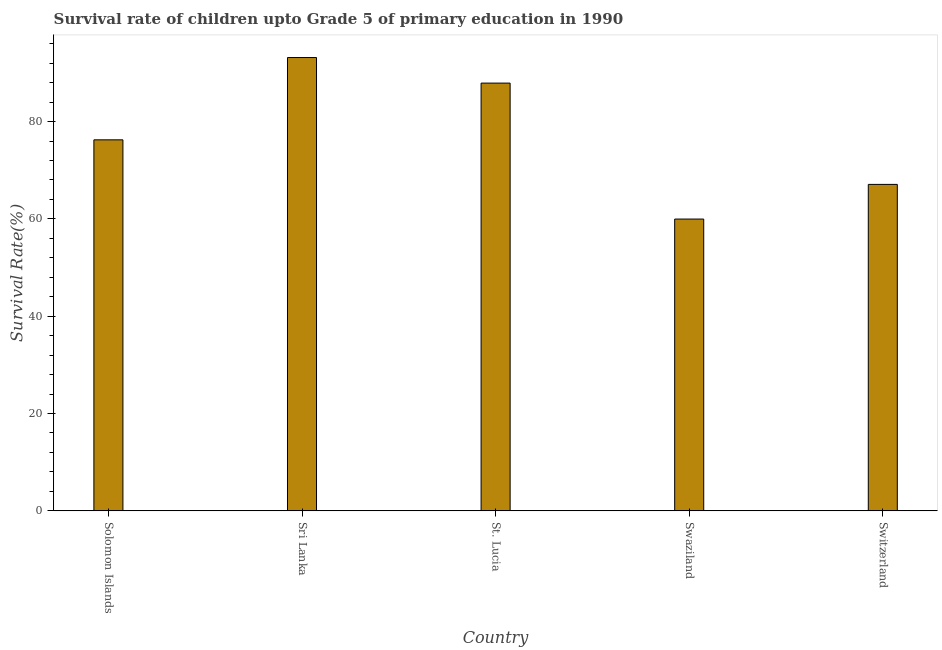Does the graph contain any zero values?
Your response must be concise. No. What is the title of the graph?
Ensure brevity in your answer.  Survival rate of children upto Grade 5 of primary education in 1990 . What is the label or title of the Y-axis?
Keep it short and to the point. Survival Rate(%). What is the survival rate in St. Lucia?
Ensure brevity in your answer.  87.9. Across all countries, what is the maximum survival rate?
Your answer should be very brief. 93.16. Across all countries, what is the minimum survival rate?
Ensure brevity in your answer.  59.96. In which country was the survival rate maximum?
Ensure brevity in your answer.  Sri Lanka. In which country was the survival rate minimum?
Keep it short and to the point. Swaziland. What is the sum of the survival rate?
Keep it short and to the point. 384.35. What is the difference between the survival rate in Solomon Islands and Switzerland?
Make the answer very short. 9.16. What is the average survival rate per country?
Offer a terse response. 76.87. What is the median survival rate?
Your answer should be very brief. 76.24. In how many countries, is the survival rate greater than 32 %?
Provide a short and direct response. 5. What is the ratio of the survival rate in Solomon Islands to that in St. Lucia?
Your answer should be very brief. 0.87. Is the difference between the survival rate in Solomon Islands and St. Lucia greater than the difference between any two countries?
Keep it short and to the point. No. What is the difference between the highest and the second highest survival rate?
Give a very brief answer. 5.25. Is the sum of the survival rate in Swaziland and Switzerland greater than the maximum survival rate across all countries?
Offer a terse response. Yes. What is the difference between the highest and the lowest survival rate?
Your answer should be compact. 33.19. In how many countries, is the survival rate greater than the average survival rate taken over all countries?
Offer a very short reply. 2. How many bars are there?
Give a very brief answer. 5. Are all the bars in the graph horizontal?
Give a very brief answer. No. How many countries are there in the graph?
Provide a succinct answer. 5. What is the difference between two consecutive major ticks on the Y-axis?
Make the answer very short. 20. Are the values on the major ticks of Y-axis written in scientific E-notation?
Your answer should be very brief. No. What is the Survival Rate(%) of Solomon Islands?
Your answer should be very brief. 76.24. What is the Survival Rate(%) of Sri Lanka?
Provide a succinct answer. 93.16. What is the Survival Rate(%) of St. Lucia?
Your response must be concise. 87.9. What is the Survival Rate(%) in Swaziland?
Your response must be concise. 59.96. What is the Survival Rate(%) of Switzerland?
Your answer should be very brief. 67.08. What is the difference between the Survival Rate(%) in Solomon Islands and Sri Lanka?
Offer a very short reply. -16.91. What is the difference between the Survival Rate(%) in Solomon Islands and St. Lucia?
Give a very brief answer. -11.66. What is the difference between the Survival Rate(%) in Solomon Islands and Swaziland?
Make the answer very short. 16.28. What is the difference between the Survival Rate(%) in Solomon Islands and Switzerland?
Your answer should be very brief. 9.16. What is the difference between the Survival Rate(%) in Sri Lanka and St. Lucia?
Your answer should be very brief. 5.25. What is the difference between the Survival Rate(%) in Sri Lanka and Swaziland?
Give a very brief answer. 33.19. What is the difference between the Survival Rate(%) in Sri Lanka and Switzerland?
Your answer should be very brief. 26.07. What is the difference between the Survival Rate(%) in St. Lucia and Swaziland?
Make the answer very short. 27.94. What is the difference between the Survival Rate(%) in St. Lucia and Switzerland?
Make the answer very short. 20.82. What is the difference between the Survival Rate(%) in Swaziland and Switzerland?
Keep it short and to the point. -7.12. What is the ratio of the Survival Rate(%) in Solomon Islands to that in Sri Lanka?
Your answer should be compact. 0.82. What is the ratio of the Survival Rate(%) in Solomon Islands to that in St. Lucia?
Your answer should be very brief. 0.87. What is the ratio of the Survival Rate(%) in Solomon Islands to that in Swaziland?
Provide a short and direct response. 1.27. What is the ratio of the Survival Rate(%) in Solomon Islands to that in Switzerland?
Make the answer very short. 1.14. What is the ratio of the Survival Rate(%) in Sri Lanka to that in St. Lucia?
Your answer should be very brief. 1.06. What is the ratio of the Survival Rate(%) in Sri Lanka to that in Swaziland?
Offer a very short reply. 1.55. What is the ratio of the Survival Rate(%) in Sri Lanka to that in Switzerland?
Provide a succinct answer. 1.39. What is the ratio of the Survival Rate(%) in St. Lucia to that in Swaziland?
Make the answer very short. 1.47. What is the ratio of the Survival Rate(%) in St. Lucia to that in Switzerland?
Provide a succinct answer. 1.31. What is the ratio of the Survival Rate(%) in Swaziland to that in Switzerland?
Your answer should be very brief. 0.89. 